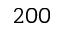Convert formula to latex. <formula><loc_0><loc_0><loc_500><loc_500>2 0 0</formula> 